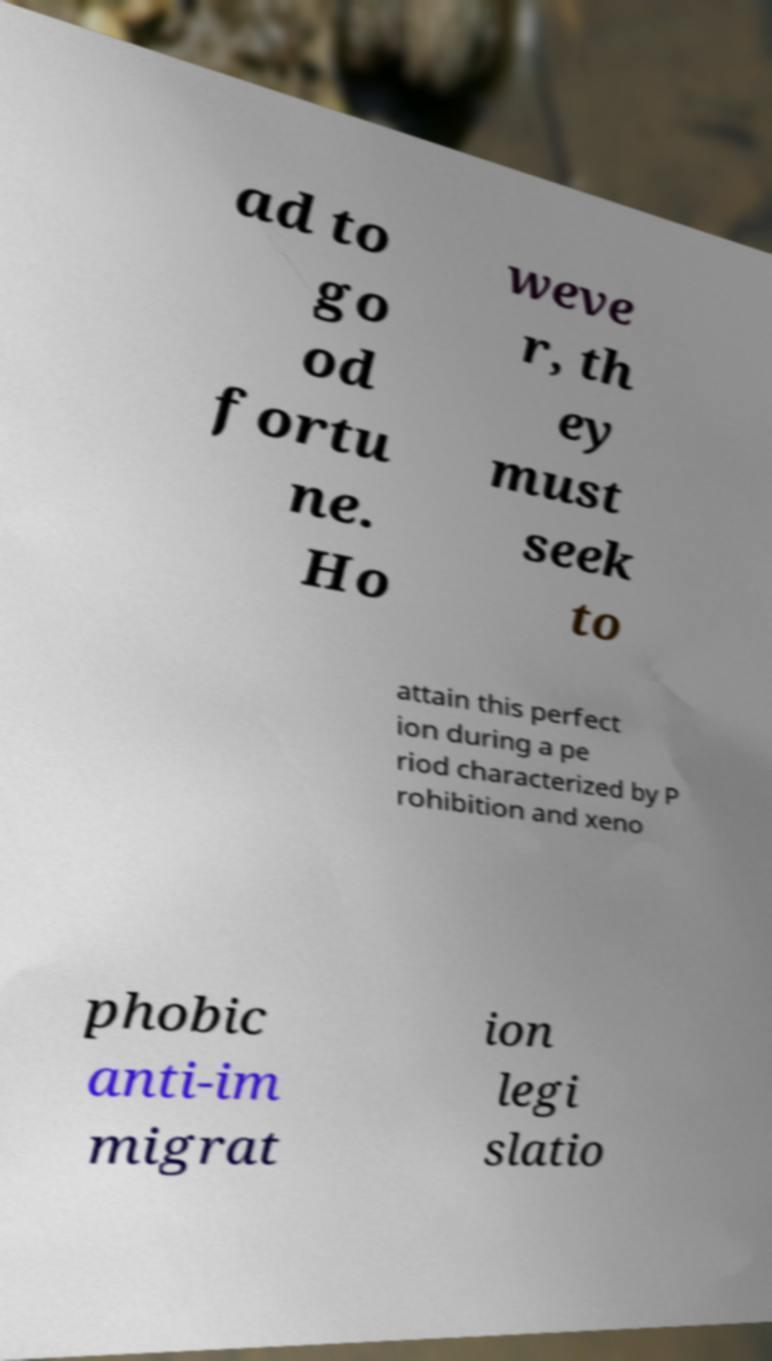Could you assist in decoding the text presented in this image and type it out clearly? ad to go od fortu ne. Ho weve r, th ey must seek to attain this perfect ion during a pe riod characterized by P rohibition and xeno phobic anti-im migrat ion legi slatio 